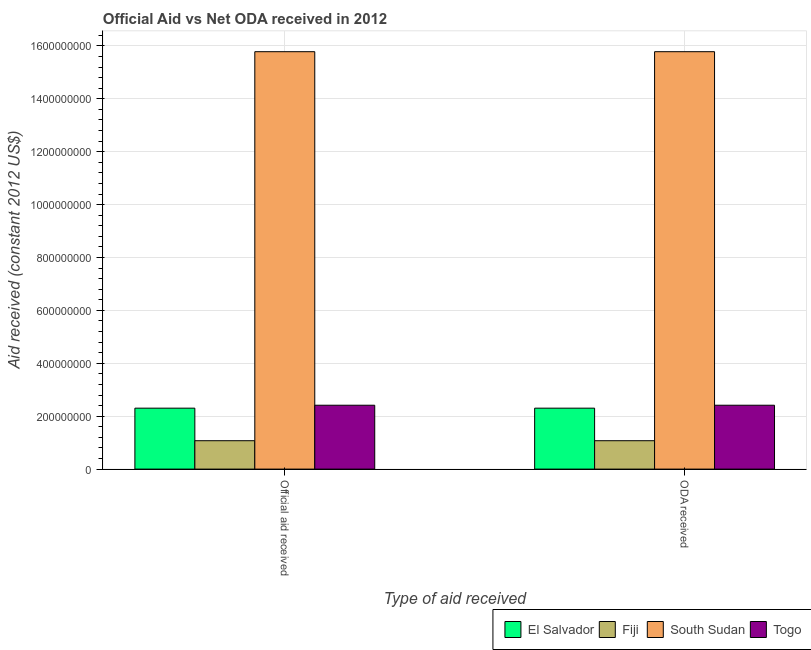How many different coloured bars are there?
Offer a terse response. 4. How many groups of bars are there?
Offer a very short reply. 2. How many bars are there on the 1st tick from the right?
Give a very brief answer. 4. What is the label of the 2nd group of bars from the left?
Keep it short and to the point. ODA received. What is the official aid received in Togo?
Give a very brief answer. 2.41e+08. Across all countries, what is the maximum oda received?
Your response must be concise. 1.58e+09. Across all countries, what is the minimum oda received?
Give a very brief answer. 1.07e+08. In which country was the oda received maximum?
Your answer should be very brief. South Sudan. In which country was the oda received minimum?
Make the answer very short. Fiji. What is the total official aid received in the graph?
Provide a succinct answer. 2.16e+09. What is the difference between the oda received in South Sudan and that in Togo?
Give a very brief answer. 1.34e+09. What is the difference between the oda received in El Salvador and the official aid received in Fiji?
Offer a terse response. 1.23e+08. What is the average official aid received per country?
Keep it short and to the point. 5.39e+08. What is the difference between the official aid received and oda received in Fiji?
Provide a short and direct response. 0. What is the ratio of the oda received in Fiji to that in South Sudan?
Offer a terse response. 0.07. Is the oda received in El Salvador less than that in South Sudan?
Provide a short and direct response. Yes. What does the 3rd bar from the left in Official aid received represents?
Your response must be concise. South Sudan. What does the 2nd bar from the right in Official aid received represents?
Make the answer very short. South Sudan. Are all the bars in the graph horizontal?
Ensure brevity in your answer.  No. What is the difference between two consecutive major ticks on the Y-axis?
Give a very brief answer. 2.00e+08. Are the values on the major ticks of Y-axis written in scientific E-notation?
Your response must be concise. No. What is the title of the graph?
Offer a very short reply. Official Aid vs Net ODA received in 2012 . Does "Ethiopia" appear as one of the legend labels in the graph?
Make the answer very short. No. What is the label or title of the X-axis?
Keep it short and to the point. Type of aid received. What is the label or title of the Y-axis?
Provide a succinct answer. Aid received (constant 2012 US$). What is the Aid received (constant 2012 US$) in El Salvador in Official aid received?
Give a very brief answer. 2.30e+08. What is the Aid received (constant 2012 US$) in Fiji in Official aid received?
Give a very brief answer. 1.07e+08. What is the Aid received (constant 2012 US$) in South Sudan in Official aid received?
Provide a succinct answer. 1.58e+09. What is the Aid received (constant 2012 US$) of Togo in Official aid received?
Your answer should be compact. 2.41e+08. What is the Aid received (constant 2012 US$) of El Salvador in ODA received?
Provide a succinct answer. 2.30e+08. What is the Aid received (constant 2012 US$) of Fiji in ODA received?
Make the answer very short. 1.07e+08. What is the Aid received (constant 2012 US$) in South Sudan in ODA received?
Ensure brevity in your answer.  1.58e+09. What is the Aid received (constant 2012 US$) of Togo in ODA received?
Your answer should be very brief. 2.41e+08. Across all Type of aid received, what is the maximum Aid received (constant 2012 US$) in El Salvador?
Offer a terse response. 2.30e+08. Across all Type of aid received, what is the maximum Aid received (constant 2012 US$) of Fiji?
Make the answer very short. 1.07e+08. Across all Type of aid received, what is the maximum Aid received (constant 2012 US$) of South Sudan?
Make the answer very short. 1.58e+09. Across all Type of aid received, what is the maximum Aid received (constant 2012 US$) in Togo?
Your response must be concise. 2.41e+08. Across all Type of aid received, what is the minimum Aid received (constant 2012 US$) of El Salvador?
Your answer should be compact. 2.30e+08. Across all Type of aid received, what is the minimum Aid received (constant 2012 US$) of Fiji?
Your answer should be very brief. 1.07e+08. Across all Type of aid received, what is the minimum Aid received (constant 2012 US$) in South Sudan?
Offer a very short reply. 1.58e+09. Across all Type of aid received, what is the minimum Aid received (constant 2012 US$) of Togo?
Offer a very short reply. 2.41e+08. What is the total Aid received (constant 2012 US$) in El Salvador in the graph?
Provide a succinct answer. 4.61e+08. What is the total Aid received (constant 2012 US$) of Fiji in the graph?
Provide a short and direct response. 2.15e+08. What is the total Aid received (constant 2012 US$) in South Sudan in the graph?
Provide a short and direct response. 3.16e+09. What is the total Aid received (constant 2012 US$) in Togo in the graph?
Make the answer very short. 4.83e+08. What is the difference between the Aid received (constant 2012 US$) of El Salvador in Official aid received and that in ODA received?
Ensure brevity in your answer.  0. What is the difference between the Aid received (constant 2012 US$) of South Sudan in Official aid received and that in ODA received?
Provide a succinct answer. 0. What is the difference between the Aid received (constant 2012 US$) of Togo in Official aid received and that in ODA received?
Keep it short and to the point. 0. What is the difference between the Aid received (constant 2012 US$) in El Salvador in Official aid received and the Aid received (constant 2012 US$) in Fiji in ODA received?
Offer a very short reply. 1.23e+08. What is the difference between the Aid received (constant 2012 US$) in El Salvador in Official aid received and the Aid received (constant 2012 US$) in South Sudan in ODA received?
Make the answer very short. -1.35e+09. What is the difference between the Aid received (constant 2012 US$) in El Salvador in Official aid received and the Aid received (constant 2012 US$) in Togo in ODA received?
Offer a very short reply. -1.11e+07. What is the difference between the Aid received (constant 2012 US$) in Fiji in Official aid received and the Aid received (constant 2012 US$) in South Sudan in ODA received?
Offer a terse response. -1.47e+09. What is the difference between the Aid received (constant 2012 US$) in Fiji in Official aid received and the Aid received (constant 2012 US$) in Togo in ODA received?
Your response must be concise. -1.34e+08. What is the difference between the Aid received (constant 2012 US$) of South Sudan in Official aid received and the Aid received (constant 2012 US$) of Togo in ODA received?
Provide a short and direct response. 1.34e+09. What is the average Aid received (constant 2012 US$) in El Salvador per Type of aid received?
Give a very brief answer. 2.30e+08. What is the average Aid received (constant 2012 US$) of Fiji per Type of aid received?
Keep it short and to the point. 1.07e+08. What is the average Aid received (constant 2012 US$) of South Sudan per Type of aid received?
Give a very brief answer. 1.58e+09. What is the average Aid received (constant 2012 US$) in Togo per Type of aid received?
Provide a short and direct response. 2.41e+08. What is the difference between the Aid received (constant 2012 US$) in El Salvador and Aid received (constant 2012 US$) in Fiji in Official aid received?
Your response must be concise. 1.23e+08. What is the difference between the Aid received (constant 2012 US$) in El Salvador and Aid received (constant 2012 US$) in South Sudan in Official aid received?
Give a very brief answer. -1.35e+09. What is the difference between the Aid received (constant 2012 US$) in El Salvador and Aid received (constant 2012 US$) in Togo in Official aid received?
Your answer should be compact. -1.11e+07. What is the difference between the Aid received (constant 2012 US$) of Fiji and Aid received (constant 2012 US$) of South Sudan in Official aid received?
Offer a terse response. -1.47e+09. What is the difference between the Aid received (constant 2012 US$) of Fiji and Aid received (constant 2012 US$) of Togo in Official aid received?
Ensure brevity in your answer.  -1.34e+08. What is the difference between the Aid received (constant 2012 US$) of South Sudan and Aid received (constant 2012 US$) of Togo in Official aid received?
Give a very brief answer. 1.34e+09. What is the difference between the Aid received (constant 2012 US$) in El Salvador and Aid received (constant 2012 US$) in Fiji in ODA received?
Provide a short and direct response. 1.23e+08. What is the difference between the Aid received (constant 2012 US$) in El Salvador and Aid received (constant 2012 US$) in South Sudan in ODA received?
Provide a succinct answer. -1.35e+09. What is the difference between the Aid received (constant 2012 US$) in El Salvador and Aid received (constant 2012 US$) in Togo in ODA received?
Provide a short and direct response. -1.11e+07. What is the difference between the Aid received (constant 2012 US$) of Fiji and Aid received (constant 2012 US$) of South Sudan in ODA received?
Your response must be concise. -1.47e+09. What is the difference between the Aid received (constant 2012 US$) in Fiji and Aid received (constant 2012 US$) in Togo in ODA received?
Your answer should be very brief. -1.34e+08. What is the difference between the Aid received (constant 2012 US$) in South Sudan and Aid received (constant 2012 US$) in Togo in ODA received?
Your answer should be very brief. 1.34e+09. What is the ratio of the Aid received (constant 2012 US$) in El Salvador in Official aid received to that in ODA received?
Make the answer very short. 1. What is the ratio of the Aid received (constant 2012 US$) in Fiji in Official aid received to that in ODA received?
Your answer should be very brief. 1. What is the difference between the highest and the second highest Aid received (constant 2012 US$) in El Salvador?
Provide a succinct answer. 0. What is the difference between the highest and the second highest Aid received (constant 2012 US$) in South Sudan?
Provide a short and direct response. 0. What is the difference between the highest and the lowest Aid received (constant 2012 US$) of El Salvador?
Offer a terse response. 0. What is the difference between the highest and the lowest Aid received (constant 2012 US$) in South Sudan?
Offer a very short reply. 0. 